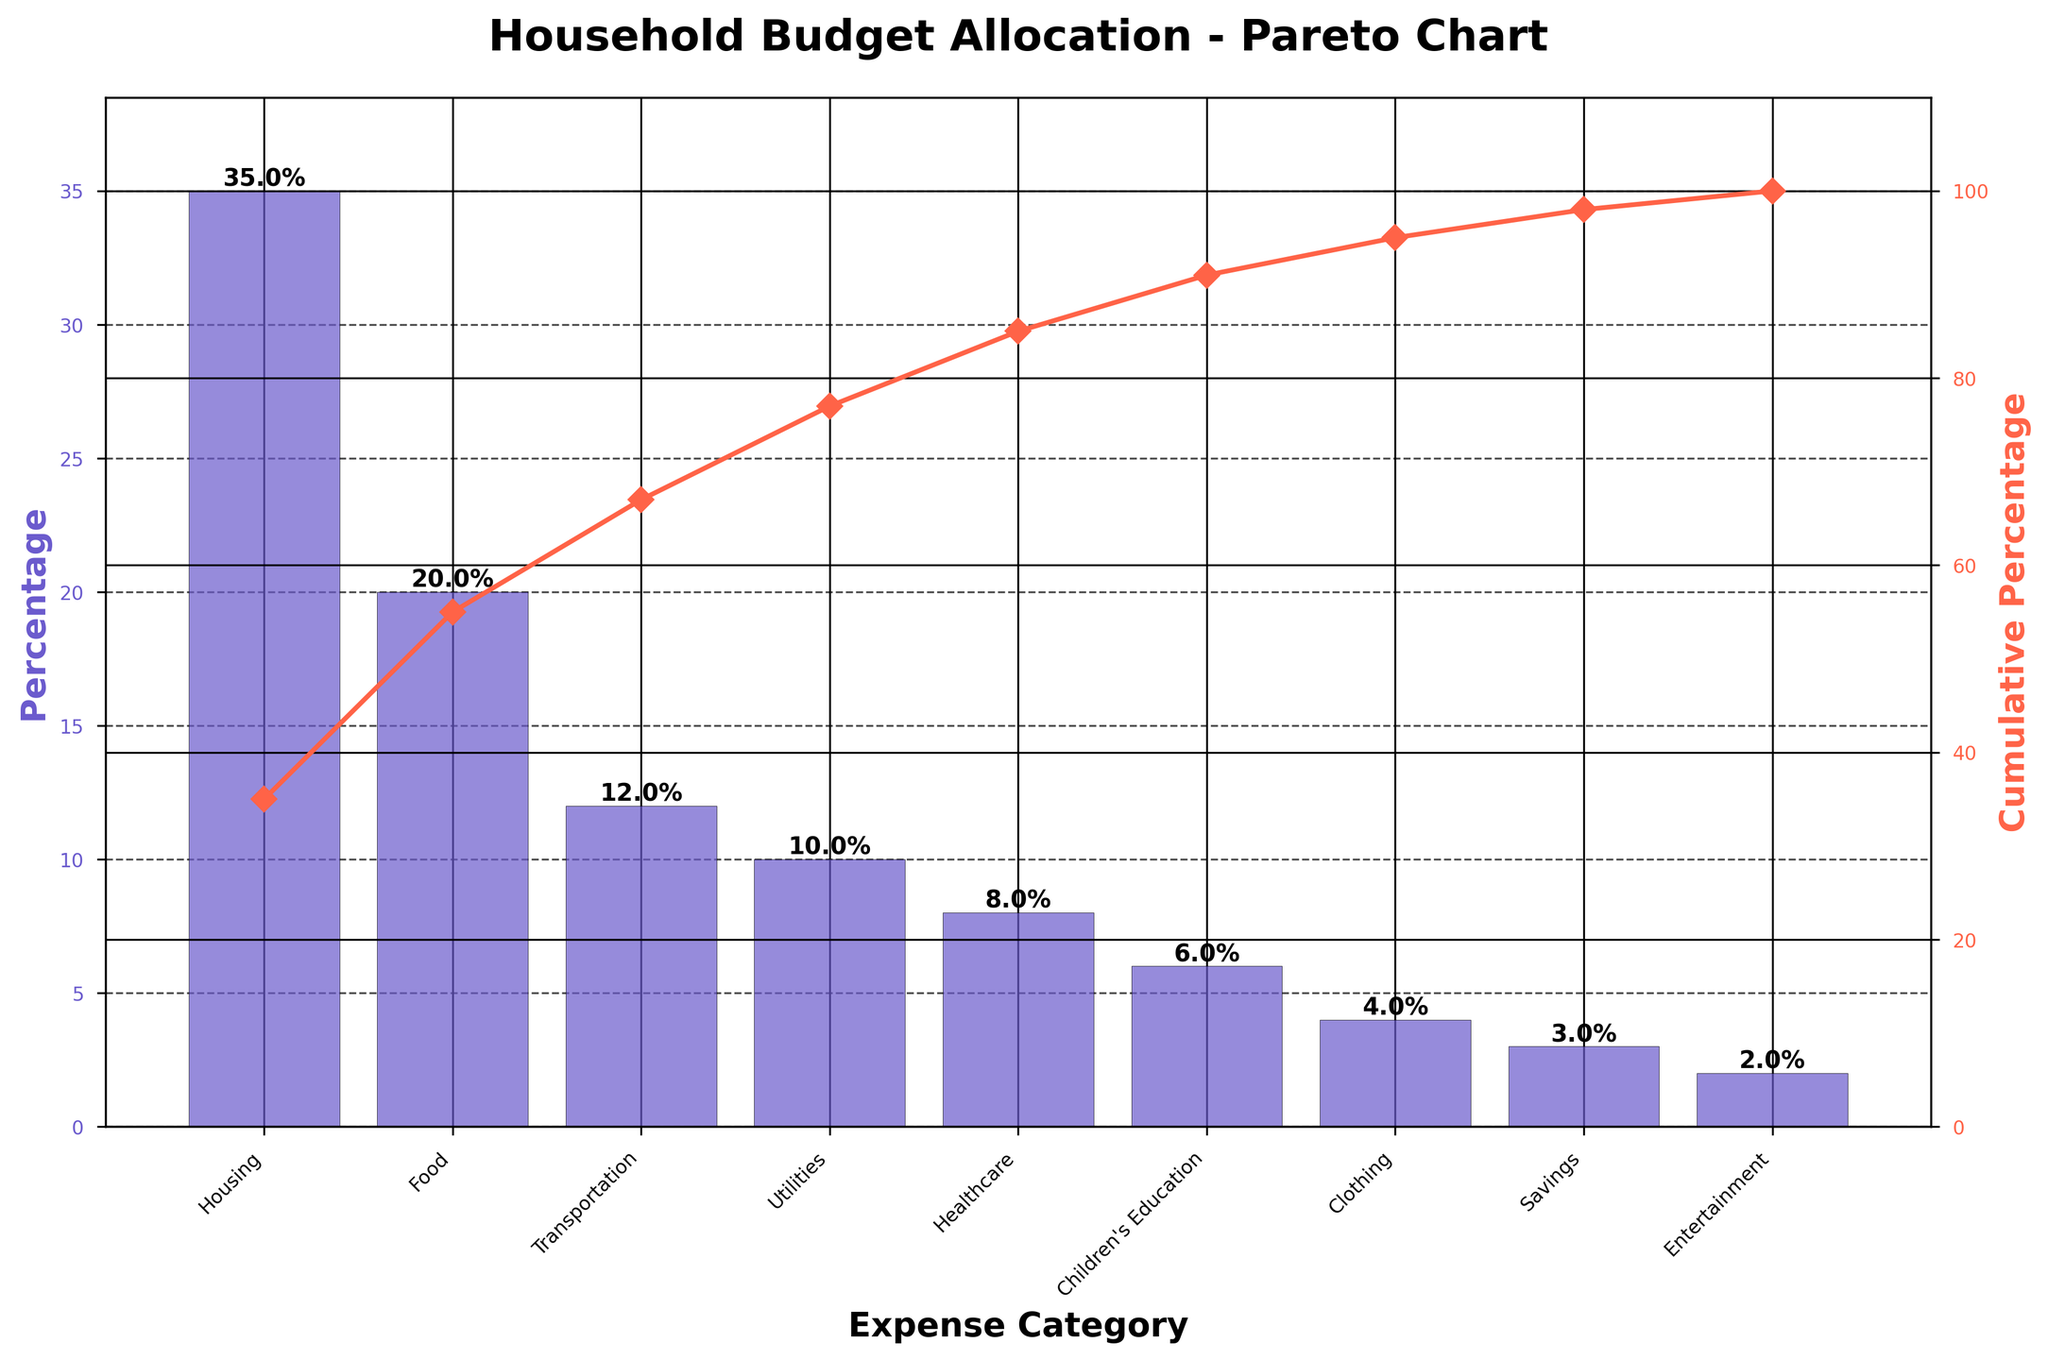What is the title of the figure? The title of the figure is usually placed at the top of the chart. In this chart, it clearly states "Household Budget Allocation - Pareto Chart".
Answer: Household Budget Allocation - Pareto Chart Which expense category has the highest percentage allocation? By looking at the height of the bars, the tallest bar represents the highest percentage allocation. The tallest bar corresponds to the "Housing" category.
Answer: Housing What is the cumulative percentage for Food and Transportation together? From the chart, the cumulative percentages are plotted on the line graph. For Food (second bar) it's 55% and for Transportation (third bar) it's 67%. By subtracting Food's cumulative from Transportation's cumulative we can find their combined contribution.
Answer: 67% How much higher is the allocation for Housing compared to Entertainment? The allocation for Housing is 35% and for Entertainment it is 2%. Subtract Entertainment from Housing (35% - 2%) to get the difference.
Answer: 33% Which two categories together first make up more than half of the total budget? The cumulative percentage line shows that the cumulative percentage for the first two bars (Housing and Food) crosses 50%. The exact values are Housing at 35% and the cumulative for Food and Housing is 55%.
Answer: Housing and Food What percentage of the total budget is allocated to Utilities? The height of the bar corresponding to Utilities is 10%.
Answer: 10% How many categories are there in total? Count the number of bars in the chart to determine the number of categories. There are 9 bars visible.
Answer: 9 If you were to save 5% of your budget, what would be the new cumulative percentage for Savings? Savings is initially at 3%. If you adjust it to 5%, look at the original cumulative for Savings (98%) and add the 2% difference to it. This will shift the overall cumulative percentage for Savings.
Answer: 100% Between Healthcare and Children's Education, which has a higher budget allocation? From the height of the bars, Healthcare has a higher allocation (8%) compared to Children's Education (6%).
Answer: Healthcare 